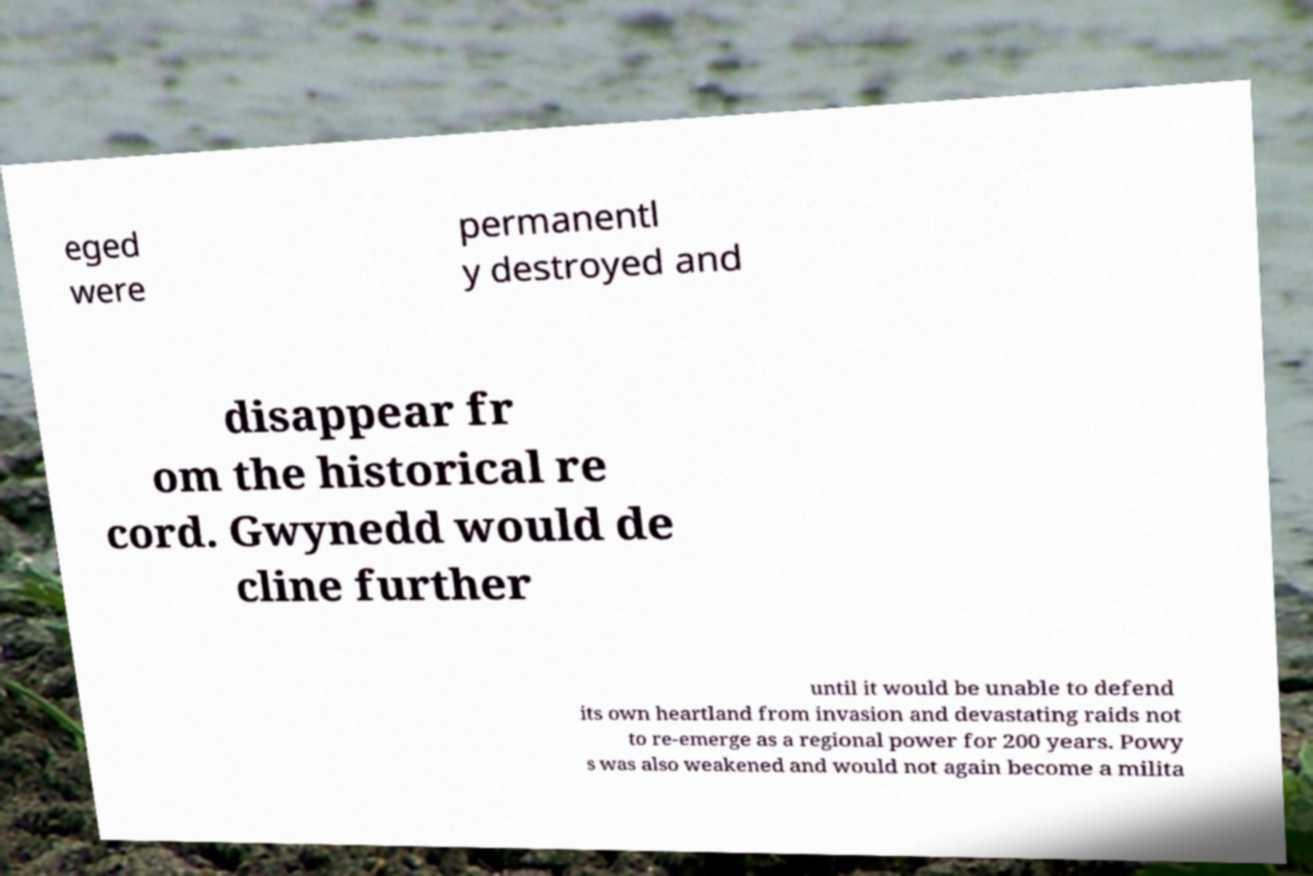Can you accurately transcribe the text from the provided image for me? eged were permanentl y destroyed and disappear fr om the historical re cord. Gwynedd would de cline further until it would be unable to defend its own heartland from invasion and devastating raids not to re-emerge as a regional power for 200 years. Powy s was also weakened and would not again become a milita 